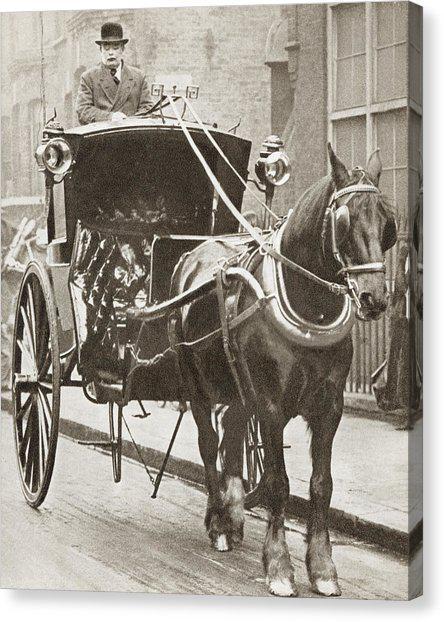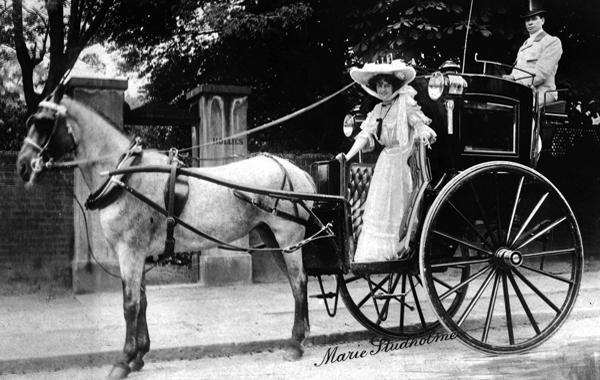The first image is the image on the left, the second image is the image on the right. Assess this claim about the two images: "The left and right image contains a total of two horses facing the opposite directions.". Correct or not? Answer yes or no. Yes. The first image is the image on the left, the second image is the image on the right. Assess this claim about the two images: "One carriage driver is holding a whip.". Correct or not? Answer yes or no. No. 